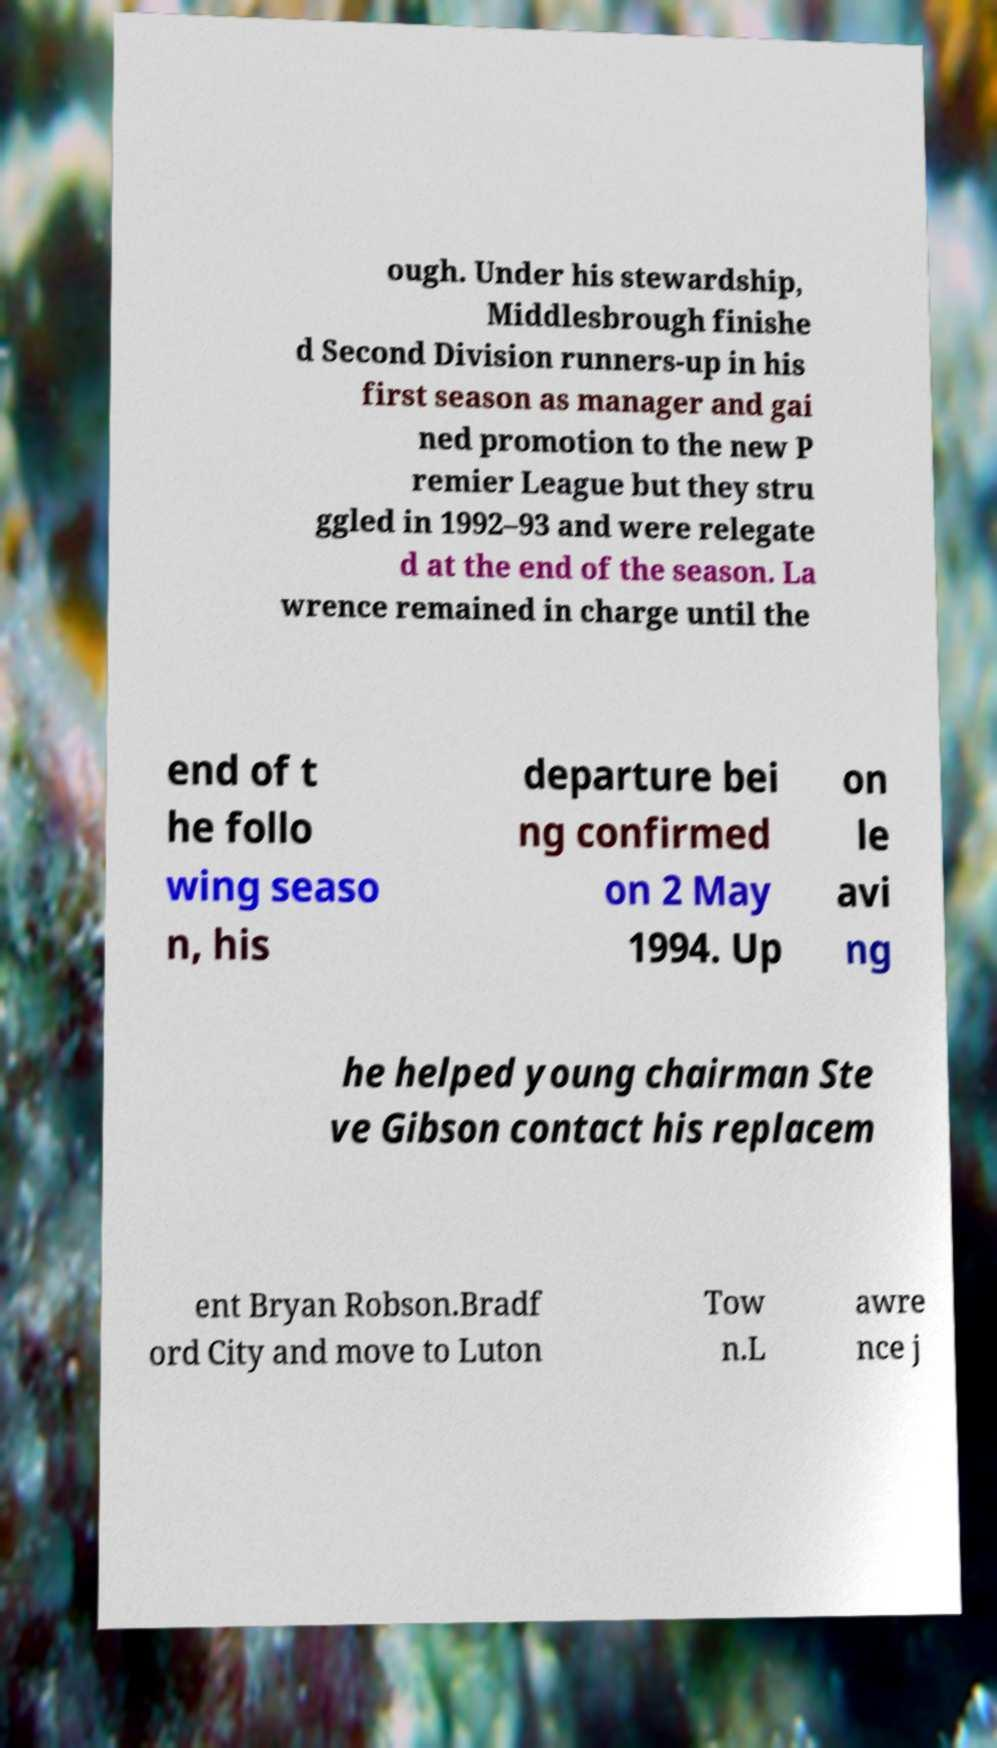For documentation purposes, I need the text within this image transcribed. Could you provide that? ough. Under his stewardship, Middlesbrough finishe d Second Division runners-up in his first season as manager and gai ned promotion to the new P remier League but they stru ggled in 1992–93 and were relegate d at the end of the season. La wrence remained in charge until the end of t he follo wing seaso n, his departure bei ng confirmed on 2 May 1994. Up on le avi ng he helped young chairman Ste ve Gibson contact his replacem ent Bryan Robson.Bradf ord City and move to Luton Tow n.L awre nce j 